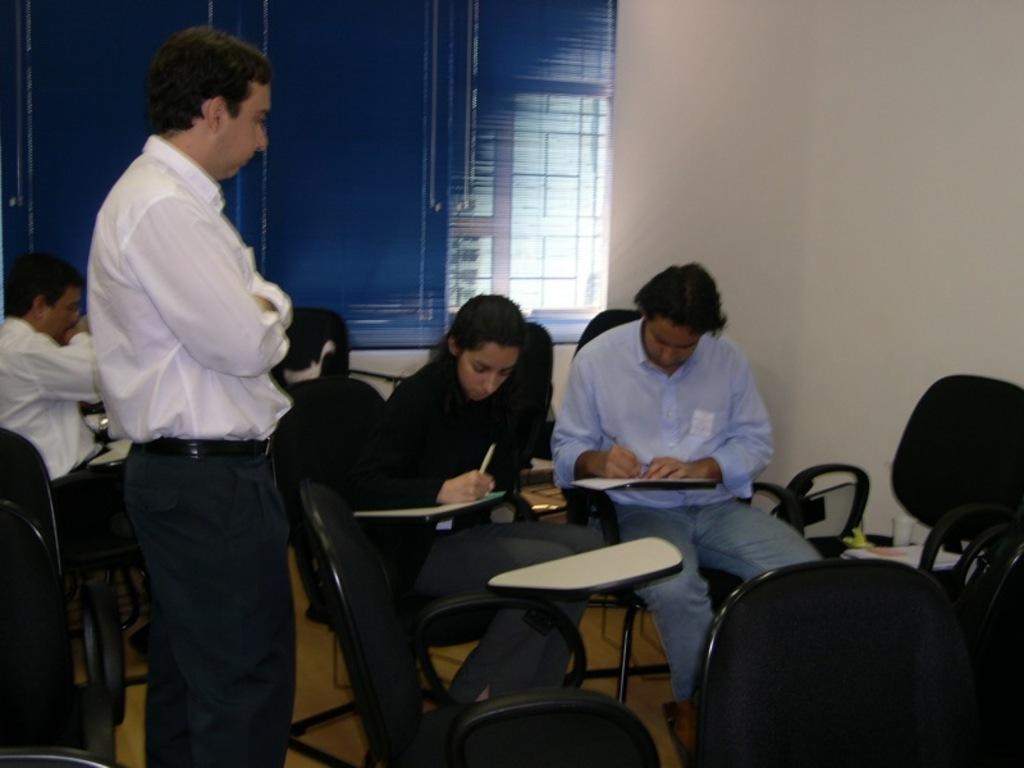How many people are in the image? There are people in the image, but the exact number is not specified. What is the position of one person in the image? One person is standing in the image. What are the other people doing in the image? The rest of the people are sitting on chairs in the image. What type of stocking is the rabbit wearing in the image? There is no rabbit or stocking present in the image. What historical event is being depicted in the image? The image does not depict any historical event; it simply shows people standing and sitting. 